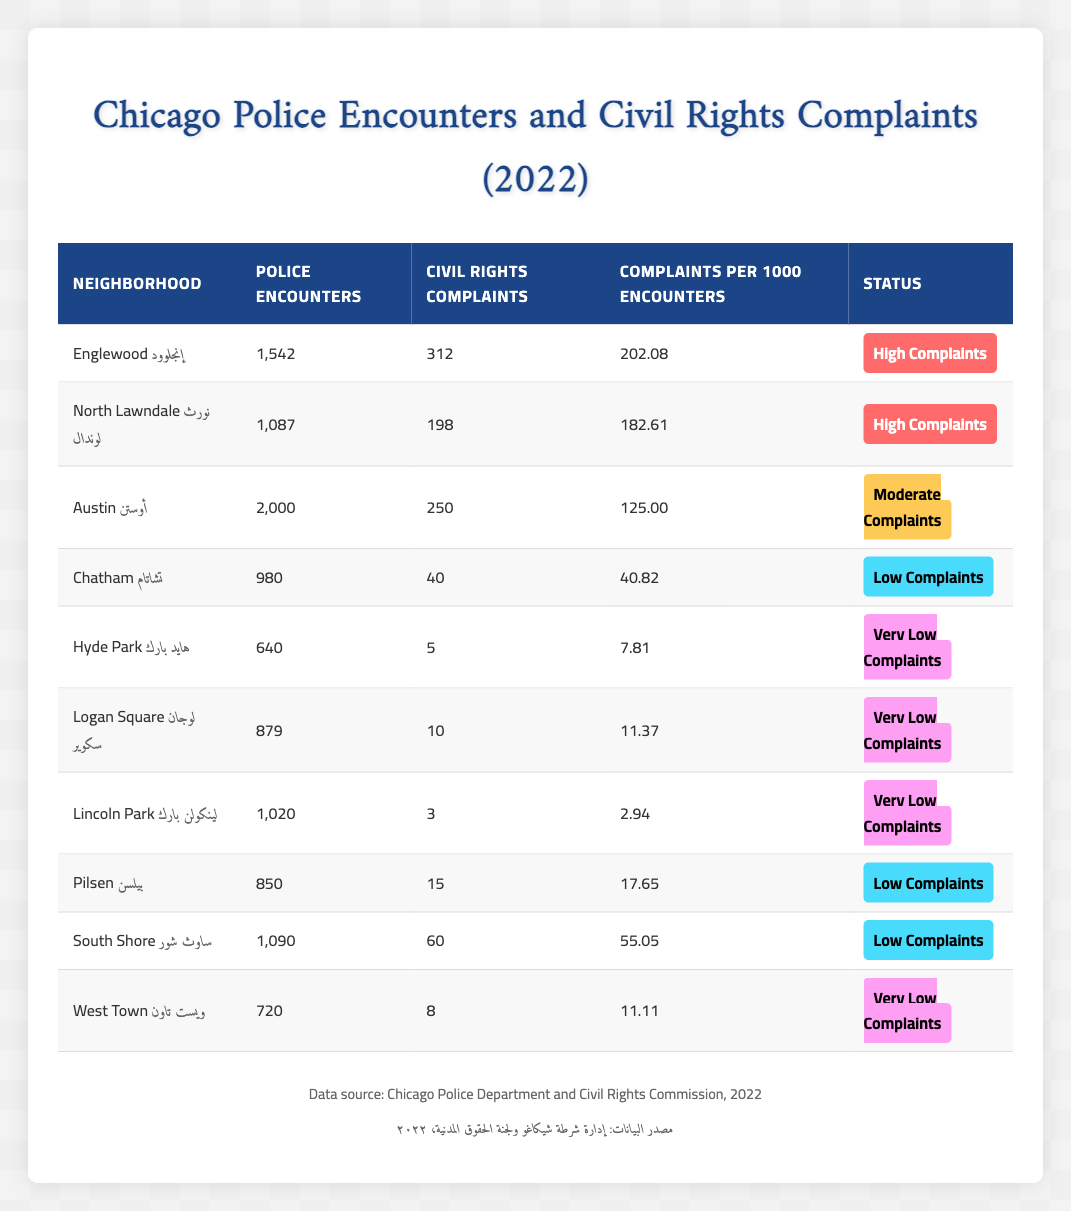What neighborhood has the highest number of police encounters? Englewood has 1,542 police encounters which is the highest among all neighborhoods listed.
Answer: Englewood How many civil rights complaints were reported in North Lawndale? North Lawndale reported 198 civil rights complaints according to the table.
Answer: 198 Which neighborhood has the lowest complaints per 1000 encounters? Lincoln Park has the lowest complaints per 1000 encounters, with a value of 2.94.
Answer: Lincoln Park What is the total number of civil rights complaints across all neighborhoods? Adding the complaints: 312 (Englewood) + 198 (North Lawndale) + 250 (Austin) + 40 (Chatham) + 5 (Hyde Park) + 10 (Logan Square) + 3 (Lincoln Park) + 15 (Pilsen) + 60 (South Shore) + 8 (West Town) gives a total of 901 complaints.
Answer: 901 True or False: Hyde Park has a high number of civil rights complaints. Hyde Park only has 5 civil rights complaints, which is categorized as "Very Low Complaints," so this statement is false.
Answer: False Which neighborhood has a moderate number of complaints? Austin, with 250 complaints and a complaints per 1000 encounters of 125.00, is categorized as having moderate complaints.
Answer: Austin If we compare the complaints in Englewood with those in South Shore, who has more? Englewood has 312 complaints while South Shore has 60 complaints, so Englewood has more complaints compared to South Shore.
Answer: Englewood What is the average number of police encounters for neighborhoods with high complaints? The sum of police encounters with high complaints is 1,542 (Englewood) + 1,087 (North Lawndale) = 2,629. There are 2 neighborhoods, so the average is 2,629 / 2 = 1,314.5.
Answer: 1,314.5 Which neighborhoods have "Very Low Complaints"? The neighborhoods categorized as having "Very Low Complaints" are Hyde Park, Logan Square, Lincoln Park, and West Town.
Answer: Hyde Park, Logan Square, Lincoln Park, West Town What is the difference in complaints per 1000 encounters between North Lawndale and Chatham? North Lawndale has 182.61 complaints per 1000 encounters, while Chatham has 40.82. The difference is 182.61 - 40.82 = 141.79.
Answer: 141.79 